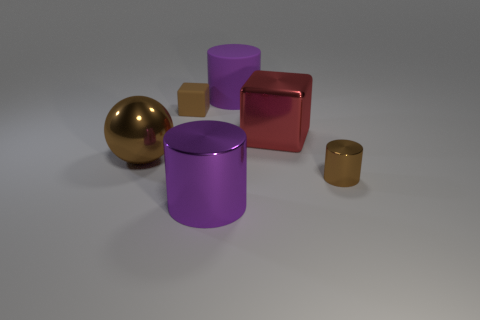Add 1 large objects. How many objects exist? 7 Subtract all blocks. How many objects are left? 4 Add 3 red shiny objects. How many red shiny objects exist? 4 Subtract 0 green cubes. How many objects are left? 6 Subtract all green matte cylinders. Subtract all small brown shiny things. How many objects are left? 5 Add 4 big brown metal spheres. How many big brown metal spheres are left? 5 